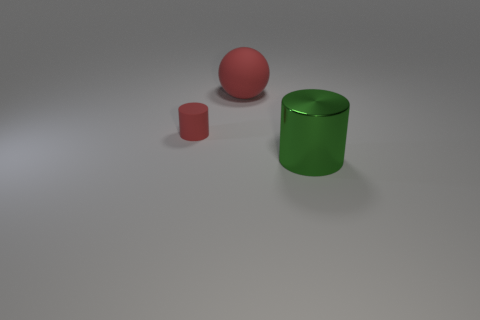Is there any other thing that has the same size as the matte cylinder?
Offer a terse response. No. What is the color of the big metallic cylinder?
Ensure brevity in your answer.  Green. Are there any tiny rubber cylinders that are on the right side of the cylinder left of the metallic thing?
Provide a short and direct response. No. What is the material of the tiny red object?
Offer a terse response. Rubber. Do the object that is to the left of the red matte sphere and the big thing behind the green object have the same material?
Your answer should be very brief. Yes. Is there anything else that is the same color as the small cylinder?
Your answer should be very brief. Yes. There is a shiny object that is the same shape as the tiny matte thing; what is its color?
Your answer should be very brief. Green. What size is the object that is on the right side of the small red cylinder and behind the green cylinder?
Offer a terse response. Large. Is the shape of the large thing that is behind the big green thing the same as the red matte object in front of the large red thing?
Ensure brevity in your answer.  No. There is a big thing that is the same color as the tiny thing; what shape is it?
Offer a very short reply. Sphere. 